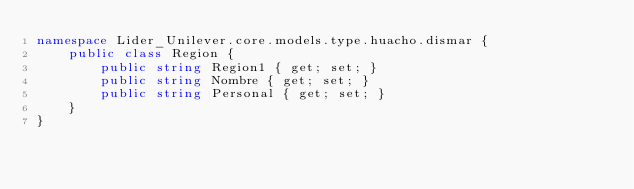<code> <loc_0><loc_0><loc_500><loc_500><_C#_>namespace Lider_Unilever.core.models.type.huacho.dismar {
    public class Region {
        public string Region1 { get; set; }
        public string Nombre { get; set; }
        public string Personal { get; set; }
    }
}</code> 